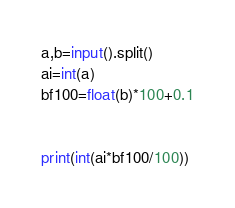<code> <loc_0><loc_0><loc_500><loc_500><_Python_>a,b=input().split()
ai=int(a)
bf100=float(b)*100+0.1
          

print(int(ai*bf100/100))
</code> 